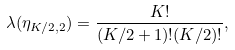Convert formula to latex. <formula><loc_0><loc_0><loc_500><loc_500>\lambda ( \eta _ { K / 2 , 2 } ) = \frac { K ! } { ( K / 2 + 1 ) ! ( K / 2 ) ! } ,</formula> 